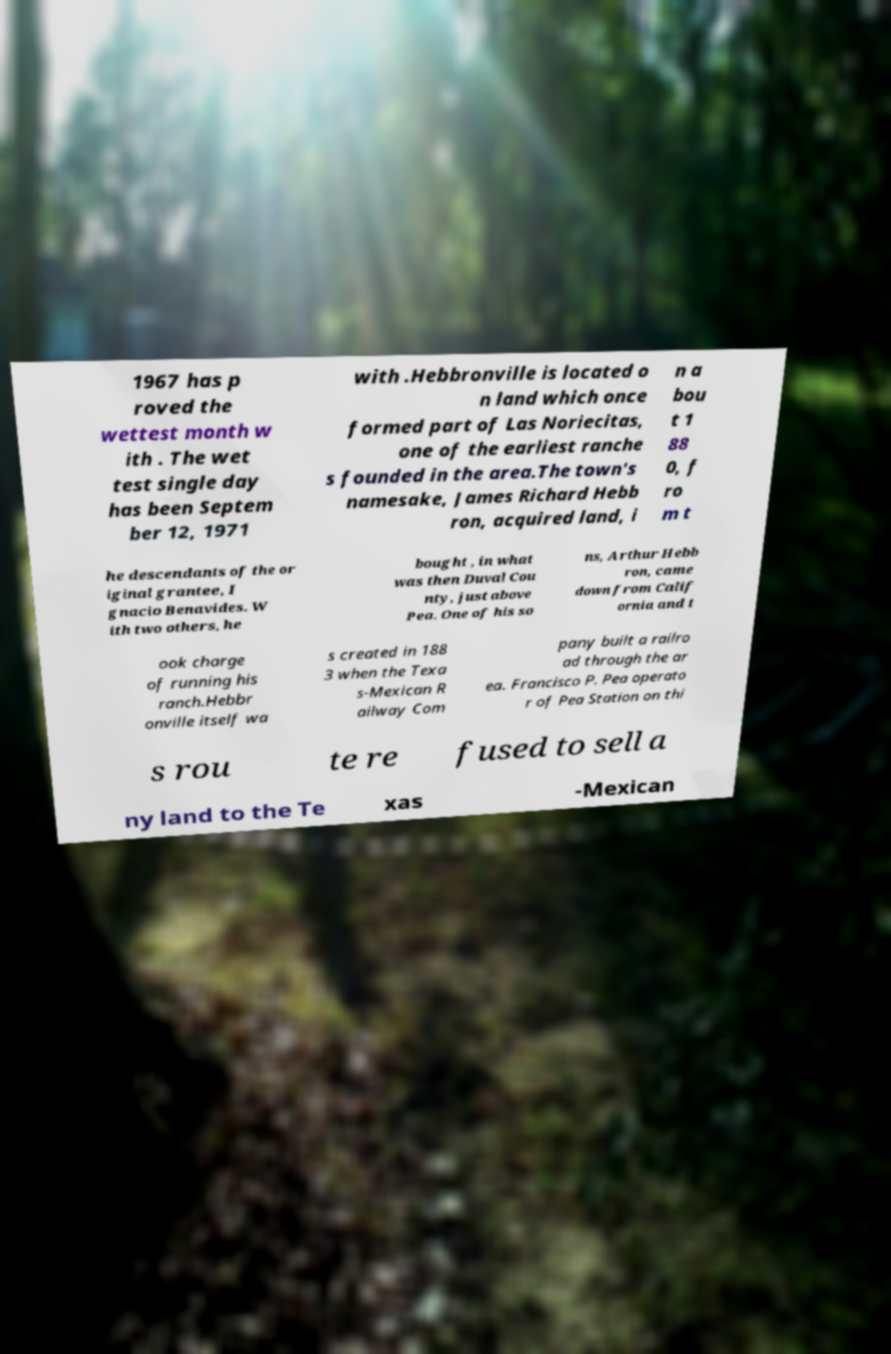Can you read and provide the text displayed in the image?This photo seems to have some interesting text. Can you extract and type it out for me? 1967 has p roved the wettest month w ith . The wet test single day has been Septem ber 12, 1971 with .Hebbronville is located o n land which once formed part of Las Noriecitas, one of the earliest ranche s founded in the area.The town's namesake, James Richard Hebb ron, acquired land, i n a bou t 1 88 0, f ro m t he descendants of the or iginal grantee, I gnacio Benavides. W ith two others, he bought , in what was then Duval Cou nty, just above Pea. One of his so ns, Arthur Hebb ron, came down from Calif ornia and t ook charge of running his ranch.Hebbr onville itself wa s created in 188 3 when the Texa s-Mexican R ailway Com pany built a railro ad through the ar ea. Francisco P. Pea operato r of Pea Station on thi s rou te re fused to sell a ny land to the Te xas -Mexican 